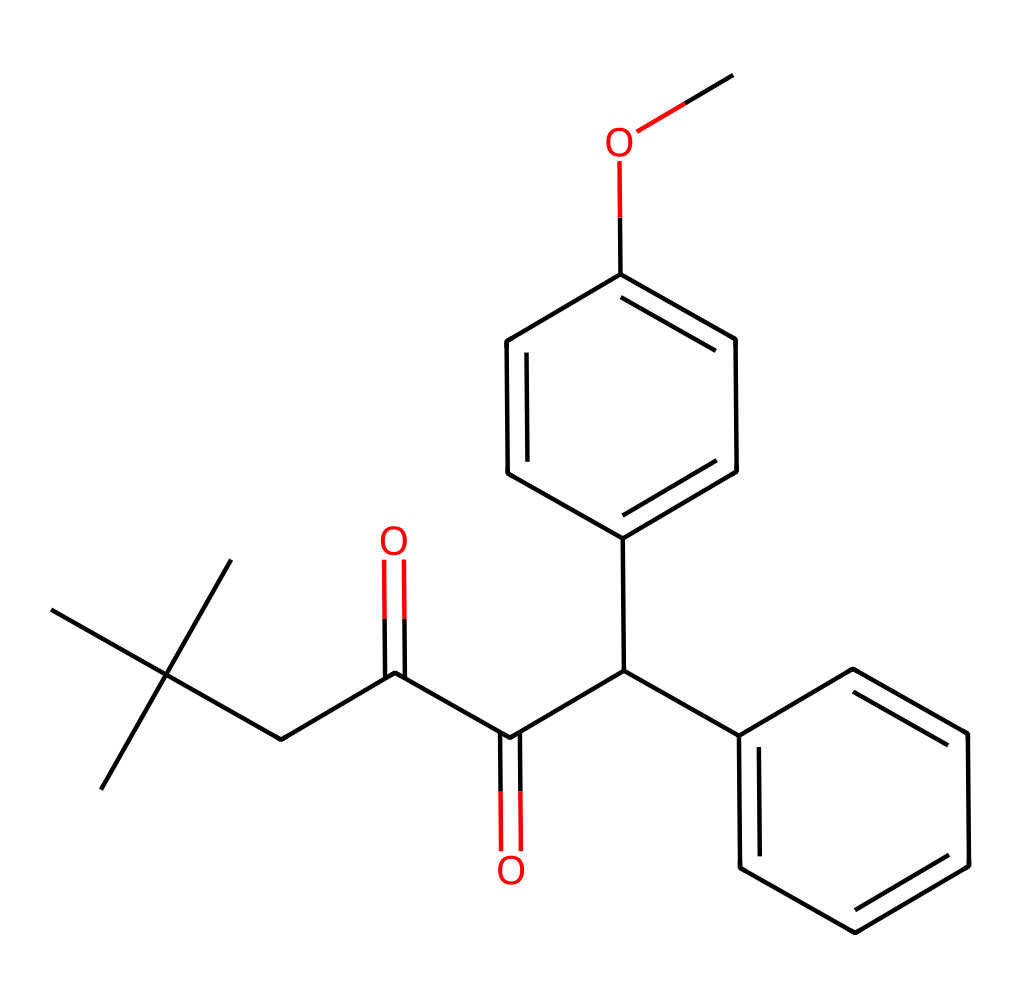What is the primary functional group present in this compound? The compound contains a carbonyl group (C=O), which is identifiable by the presence of the carbon atom double-bonded to an oxygen atom. This functional group is instrumental in defining the chemical properties of the molecule.
Answer: carbonyl How many aromatic rings are present in the structure? By analyzing the structure, there are two distinct aromatic rings indicated by the alternating double bonds characteristic of aromatic compounds. This is visually identifiable as well.
Answer: two What is the molecular formula derived from this SMILES representation? By counting all the atoms represented in the SMILES notation, we can deduce the molecular formula. The breakdown includes carbon, hydrogen, and oxygen counts, leading to the molecular formula C26H30O5.
Answer: C26H30O5 What type of compounds does this chemical represent? This structure is representative of a photoresist compound, which is used in processes like photolithography, particularly in the semiconductor industry. The specific arrangement of functional groups supports this classification.
Answer: photoresist Which part of the molecule contributes to UV resistance? The presence of specific structural features, like the conjugated double bonds in the aromatic rings, is known to contribute to UV absorption, making the compound effective in UV resistance.
Answer: aromatic rings 